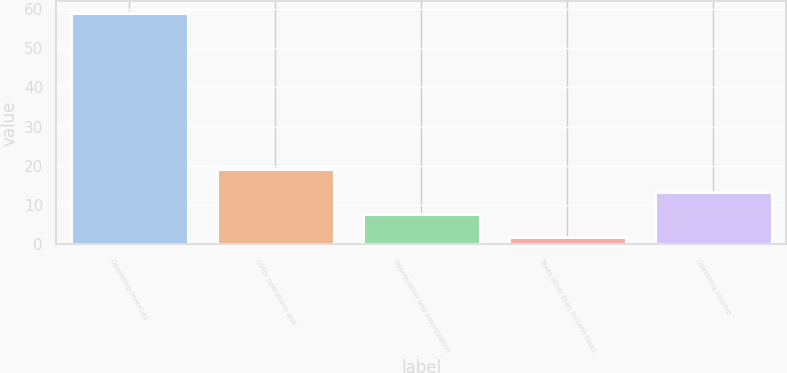Convert chart to OTSL. <chart><loc_0><loc_0><loc_500><loc_500><bar_chart><fcel>Operating revenues<fcel>Other operations and<fcel>Depreciation and amortization<fcel>Taxes other than income taxes<fcel>Operating income<nl><fcel>59<fcel>19.1<fcel>7.7<fcel>2<fcel>13.4<nl></chart> 